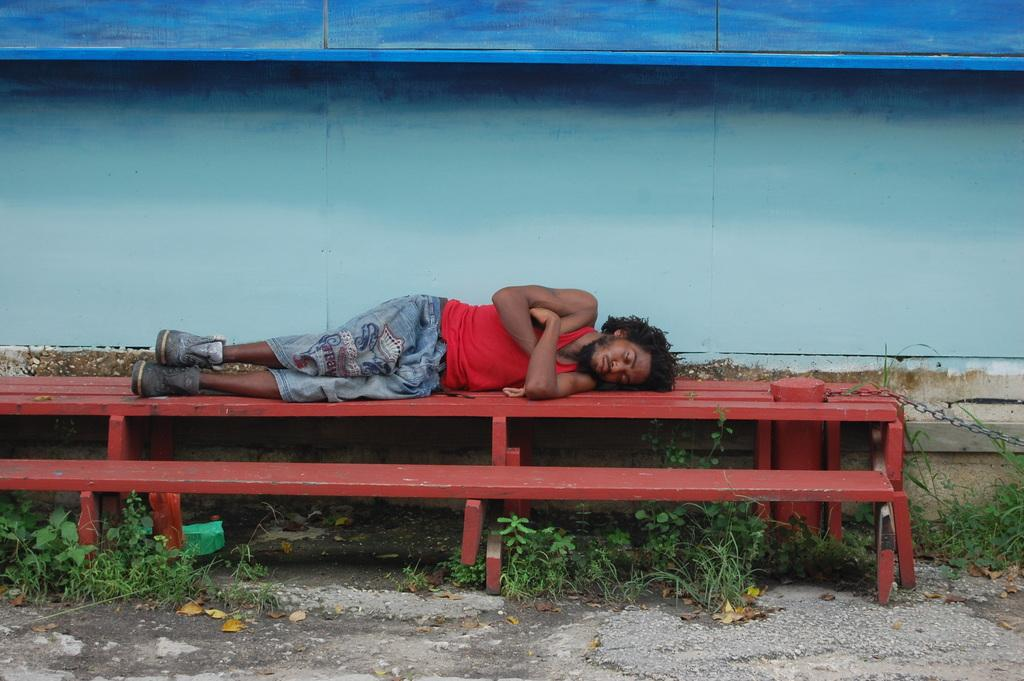What is the main subject in the foreground of the image? There is a person sleeping in the foreground of the image. Where is the person sleeping? The person is on a bench and grass. What can be seen in the background of the image? There is a wall in the background of the image. When was the image taken? The image was taken during the day. What type of servant can be seen attending to the person sleeping in the image? There is no servant present in the image; it only shows a person sleeping on a bench and grass. Are there any dinosaurs visible in the image? No, there are no dinosaurs present in the image. Can you tell me the color of the hen in the image? There is no hen present in the image. 